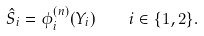Convert formula to latex. <formula><loc_0><loc_0><loc_500><loc_500>\hat { S } _ { i } = \phi _ { i } ^ { ( n ) } ( { Y } _ { i } ) \quad i \in \{ 1 , 2 \} .</formula> 